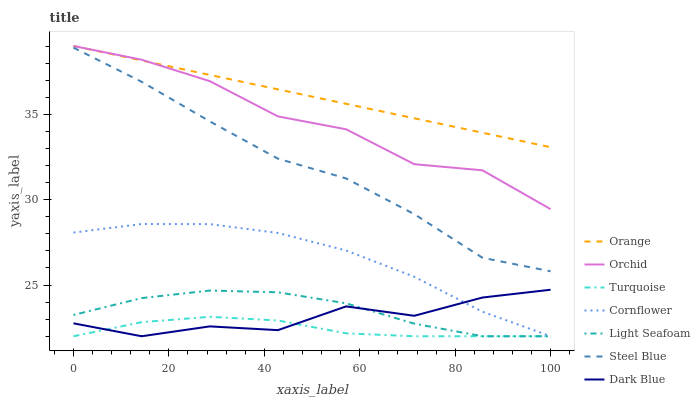Does Turquoise have the minimum area under the curve?
Answer yes or no. Yes. Does Orange have the maximum area under the curve?
Answer yes or no. Yes. Does Steel Blue have the minimum area under the curve?
Answer yes or no. No. Does Steel Blue have the maximum area under the curve?
Answer yes or no. No. Is Orange the smoothest?
Answer yes or no. Yes. Is Dark Blue the roughest?
Answer yes or no. Yes. Is Turquoise the smoothest?
Answer yes or no. No. Is Turquoise the roughest?
Answer yes or no. No. Does Cornflower have the lowest value?
Answer yes or no. Yes. Does Steel Blue have the lowest value?
Answer yes or no. No. Does Orchid have the highest value?
Answer yes or no. Yes. Does Steel Blue have the highest value?
Answer yes or no. No. Is Turquoise less than Orchid?
Answer yes or no. Yes. Is Steel Blue greater than Cornflower?
Answer yes or no. Yes. Does Light Seafoam intersect Cornflower?
Answer yes or no. Yes. Is Light Seafoam less than Cornflower?
Answer yes or no. No. Is Light Seafoam greater than Cornflower?
Answer yes or no. No. Does Turquoise intersect Orchid?
Answer yes or no. No. 